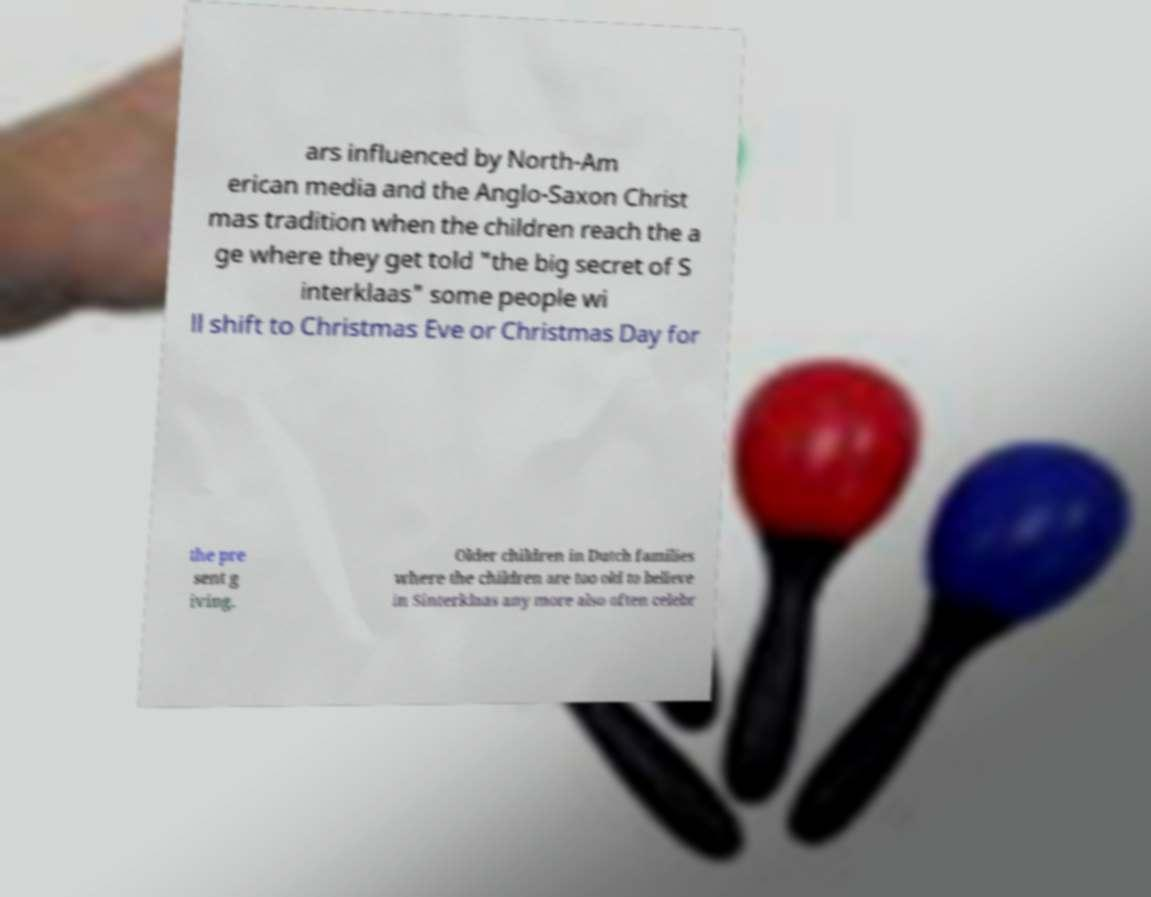Can you read and provide the text displayed in the image?This photo seems to have some interesting text. Can you extract and type it out for me? ars influenced by North-Am erican media and the Anglo-Saxon Christ mas tradition when the children reach the a ge where they get told "the big secret of S interklaas" some people wi ll shift to Christmas Eve or Christmas Day for the pre sent g iving. Older children in Dutch families where the children are too old to believe in Sinterklaas any more also often celebr 